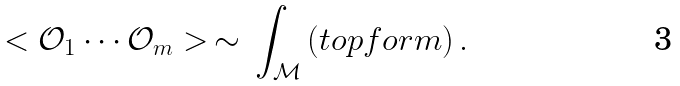<formula> <loc_0><loc_0><loc_500><loc_500>< \mathcal { O } _ { 1 } \cdots \mathcal { O } _ { m } > \, \sim \, \int _ { \mathcal { M } } \left ( t o p f o r m \right ) .</formula> 